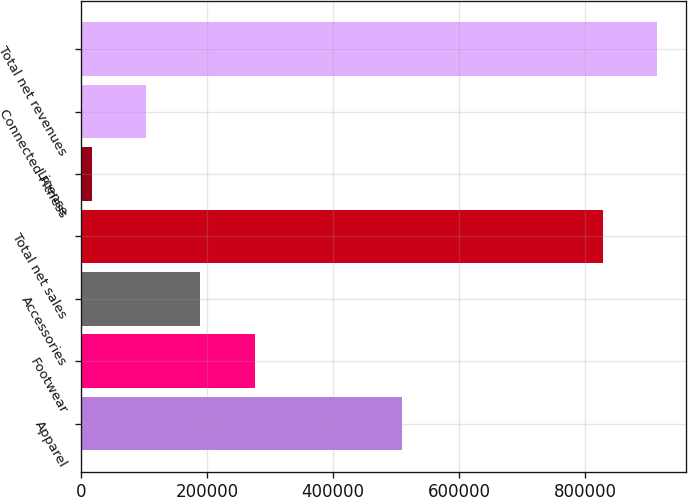Convert chart to OTSL. <chart><loc_0><loc_0><loc_500><loc_500><bar_chart><fcel>Apparel<fcel>Footwear<fcel>Accessories<fcel>Total net sales<fcel>License<fcel>Connected Fitness<fcel>Total net revenues<nl><fcel>509542<fcel>275568<fcel>189371<fcel>827775<fcel>16978<fcel>103174<fcel>913972<nl></chart> 